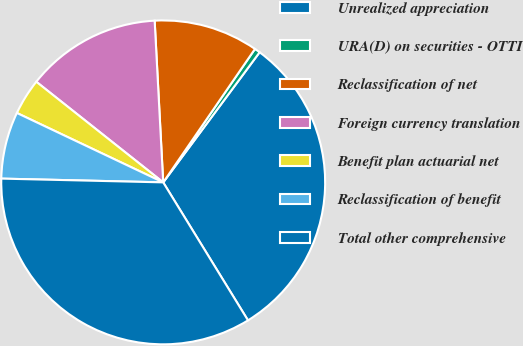Convert chart to OTSL. <chart><loc_0><loc_0><loc_500><loc_500><pie_chart><fcel>Unrealized appreciation<fcel>URA(D) on securities - OTTI<fcel>Reclassification of net<fcel>Foreign currency translation<fcel>Benefit plan actuarial net<fcel>Reclassification of benefit<fcel>Total other comprehensive<nl><fcel>31.08%<fcel>0.56%<fcel>10.43%<fcel>13.49%<fcel>3.62%<fcel>6.68%<fcel>34.14%<nl></chart> 